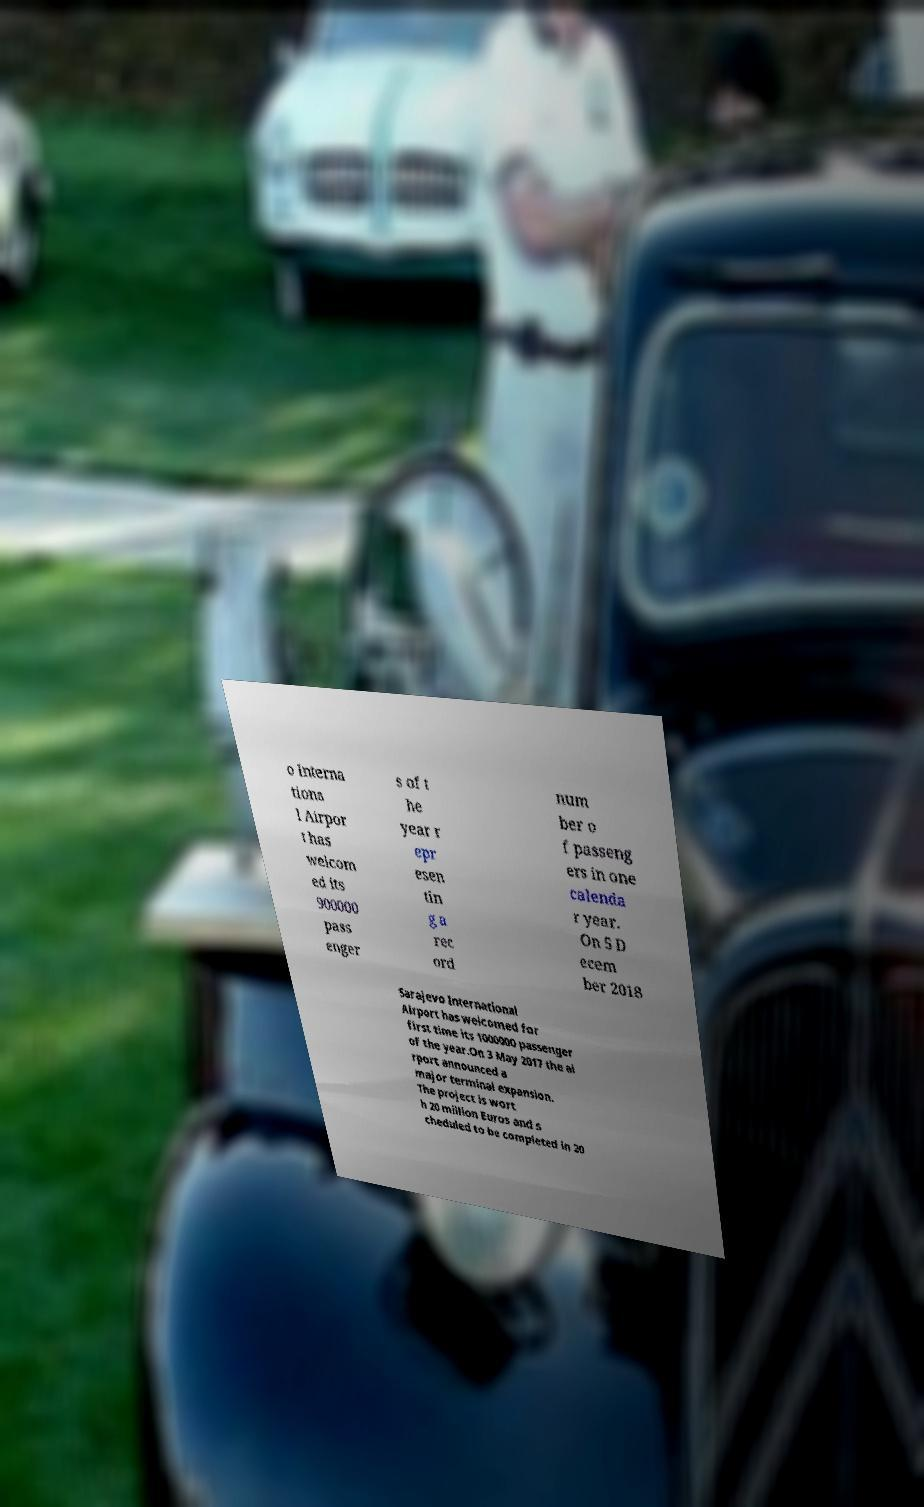Please identify and transcribe the text found in this image. o Interna tiona l Airpor t has welcom ed its 900000 pass enger s of t he year r epr esen tin g a rec ord num ber o f passeng ers in one calenda r year. On 5 D ecem ber 2018 Sarajevo International Airport has welcomed for first time its 1000000 passenger of the year.On 3 May 2017 the ai rport announced a major terminal expansion. The project is wort h 20 million Euros and s cheduled to be completed in 20 